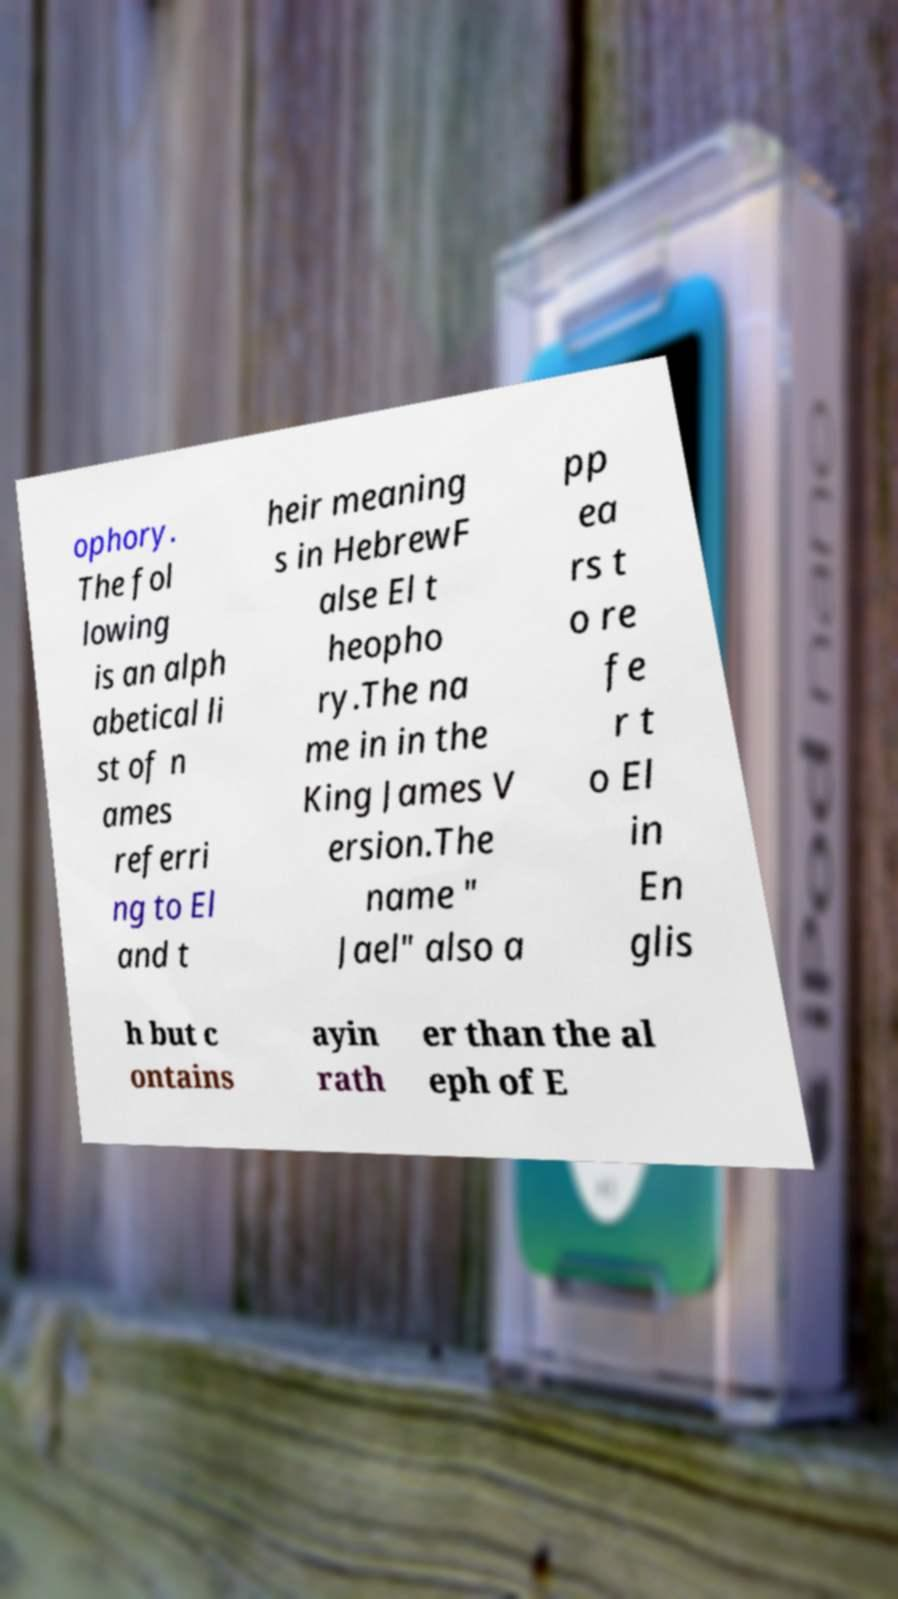Please identify and transcribe the text found in this image. ophory. The fol lowing is an alph abetical li st of n ames referri ng to El and t heir meaning s in HebrewF alse El t heopho ry.The na me in in the King James V ersion.The name " Jael" also a pp ea rs t o re fe r t o El in En glis h but c ontains ayin rath er than the al eph of E 